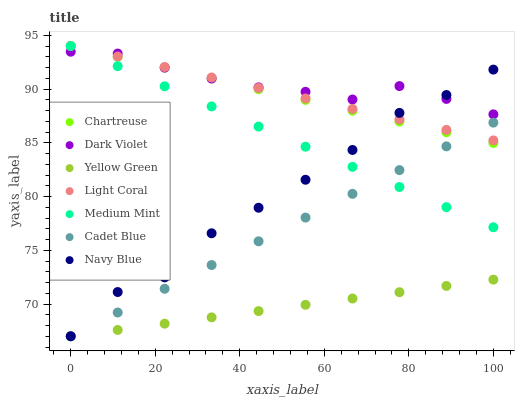Does Yellow Green have the minimum area under the curve?
Answer yes or no. Yes. Does Dark Violet have the maximum area under the curve?
Answer yes or no. Yes. Does Cadet Blue have the minimum area under the curve?
Answer yes or no. No. Does Cadet Blue have the maximum area under the curve?
Answer yes or no. No. Is Yellow Green the smoothest?
Answer yes or no. Yes. Is Navy Blue the roughest?
Answer yes or no. Yes. Is Cadet Blue the smoothest?
Answer yes or no. No. Is Cadet Blue the roughest?
Answer yes or no. No. Does Cadet Blue have the lowest value?
Answer yes or no. Yes. Does Dark Violet have the lowest value?
Answer yes or no. No. Does Chartreuse have the highest value?
Answer yes or no. Yes. Does Cadet Blue have the highest value?
Answer yes or no. No. Is Cadet Blue less than Dark Violet?
Answer yes or no. Yes. Is Chartreuse greater than Yellow Green?
Answer yes or no. Yes. Does Dark Violet intersect Medium Mint?
Answer yes or no. Yes. Is Dark Violet less than Medium Mint?
Answer yes or no. No. Is Dark Violet greater than Medium Mint?
Answer yes or no. No. Does Cadet Blue intersect Dark Violet?
Answer yes or no. No. 